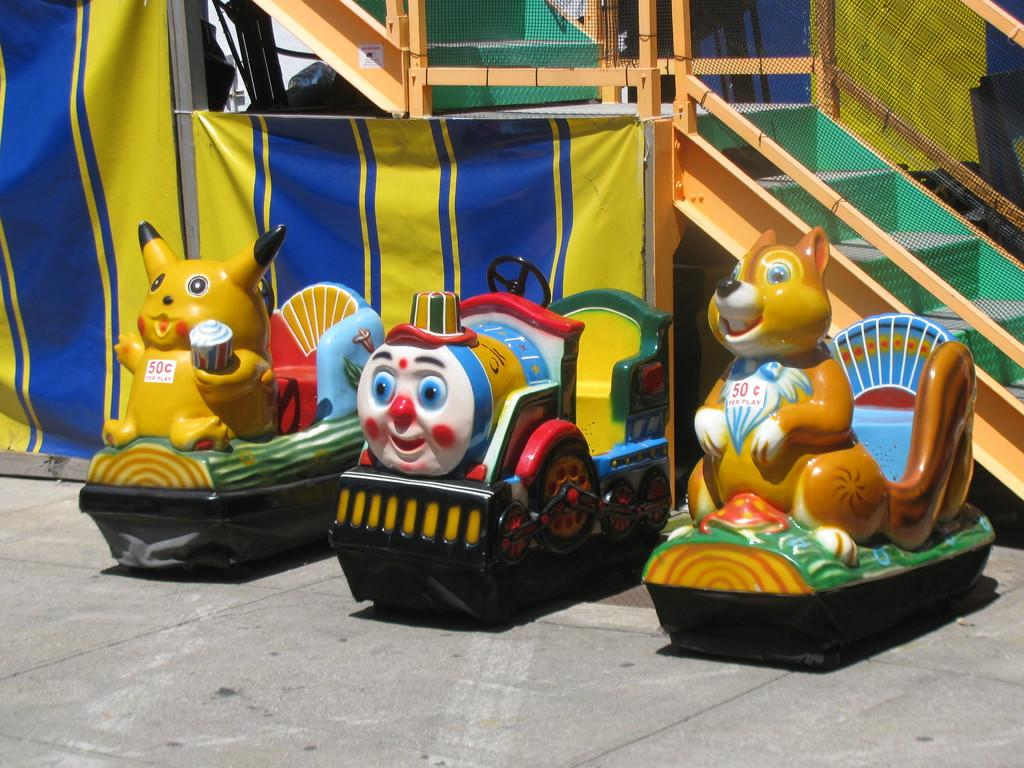What objects can be seen in the image? There are toys in the image. What type of architectural feature is visible in the background? There are wooden stairs with a railing in the backdrop. What is attached to the wooden stairs? There is a net associated with the wooden stairs. What type of flower is growing on the wooden stairs in the image? There are no flowers present on the wooden stairs in the image. 